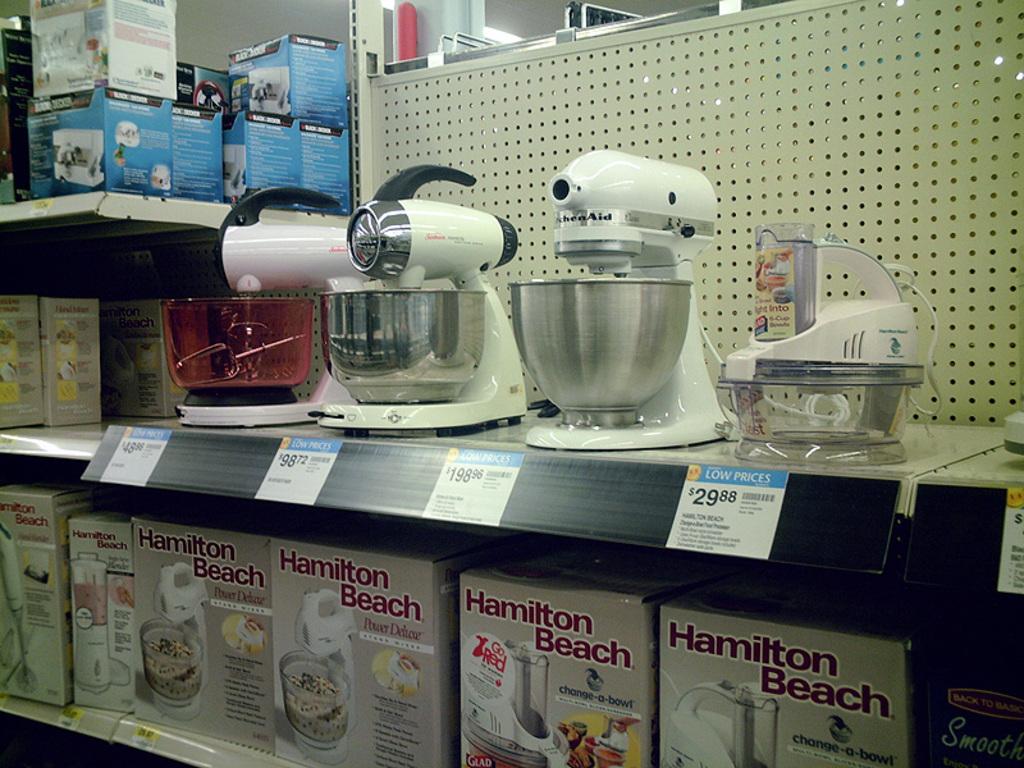What brand is the mixer?
Your response must be concise. Hamilton beach. What is the sale price of the food processor?
Ensure brevity in your answer.  29.88. 